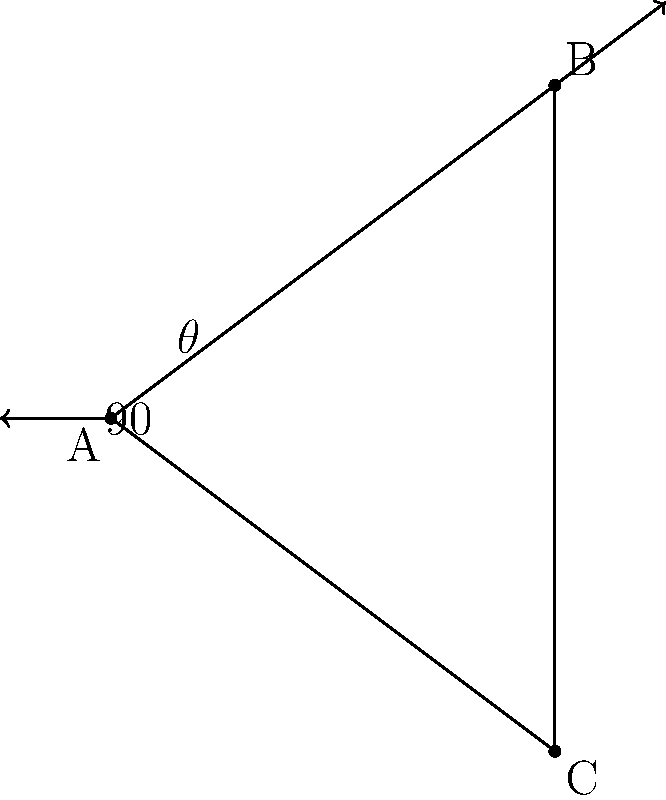Two guitar necks are arranged in a V-shape, forming a right angle at the point where they meet. If one neck is positioned at a $37°$ angle from the horizontal, what is the angle $\theta$ between the two guitar necks? Let's approach this step-by-step:

1) We know that the two guitar necks form a right angle (90°) where they meet.

2) One neck is positioned at a 37° angle from the horizontal.

3) In a right angle, the sum of the other two angles must be 90°. So if we know one of these angles, we can find the other by subtracting from 90°.

4) The angle we're looking for, $\theta$, is the angle between the two necks. This is equivalent to the angle between the 37° line and the vertical.

5) The vertical line forms a 90° angle with the horizontal. So the angle between the vertical and the 37° line is:

   $90° - 37° = 53°$

Therefore, the angle $\theta$ between the two guitar necks is 53°.
Answer: $53°$ 